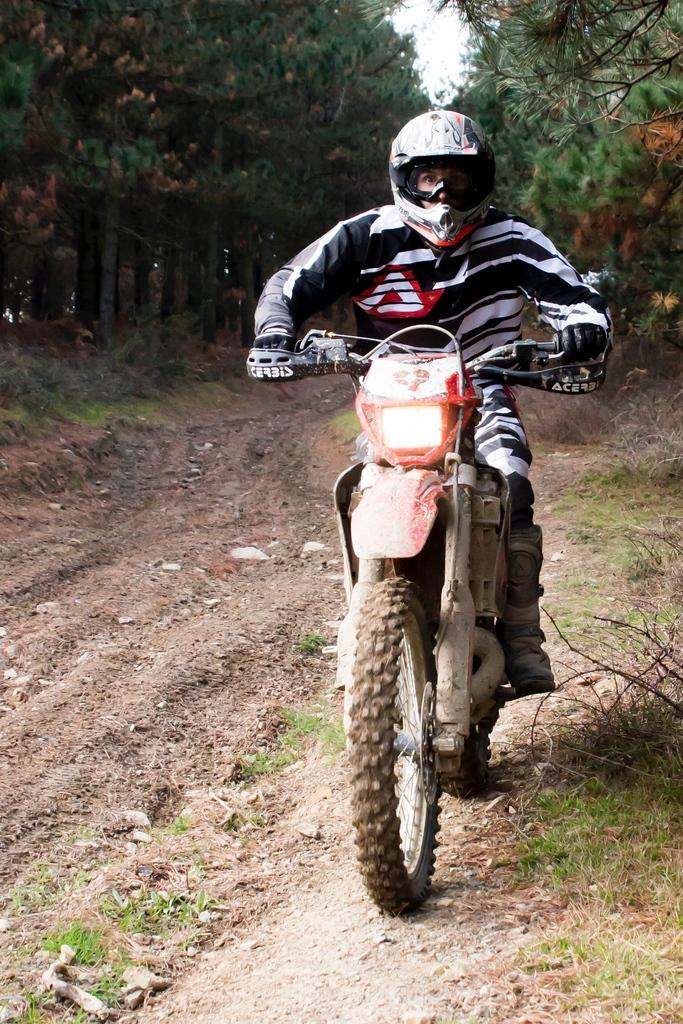What is the main subject of the image? There is a person riding a bike in the image. Where is the person riding the bike? The person is on a road. What can be seen on both sides of the road? There are trees on the right side and the left side of the road. Can you see any feathers floating in the air in the image? No, there are no feathers visible in the image. Is the person riding the bike giving a kiss to someone in the image? There is no indication of a kiss or any interaction with another person in the image. 